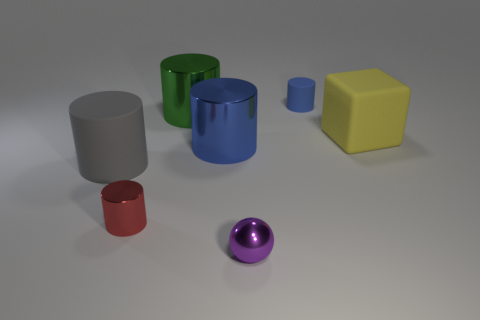Which objects in the image seem to have a reflective surface? The objects with reflective surfaces include the purple sphere, the red cylinder, and the blue cylinder. The sheen on their surfaces indicates that they are likely made of a material with a high gloss finish, such as metal or polished plastic. 